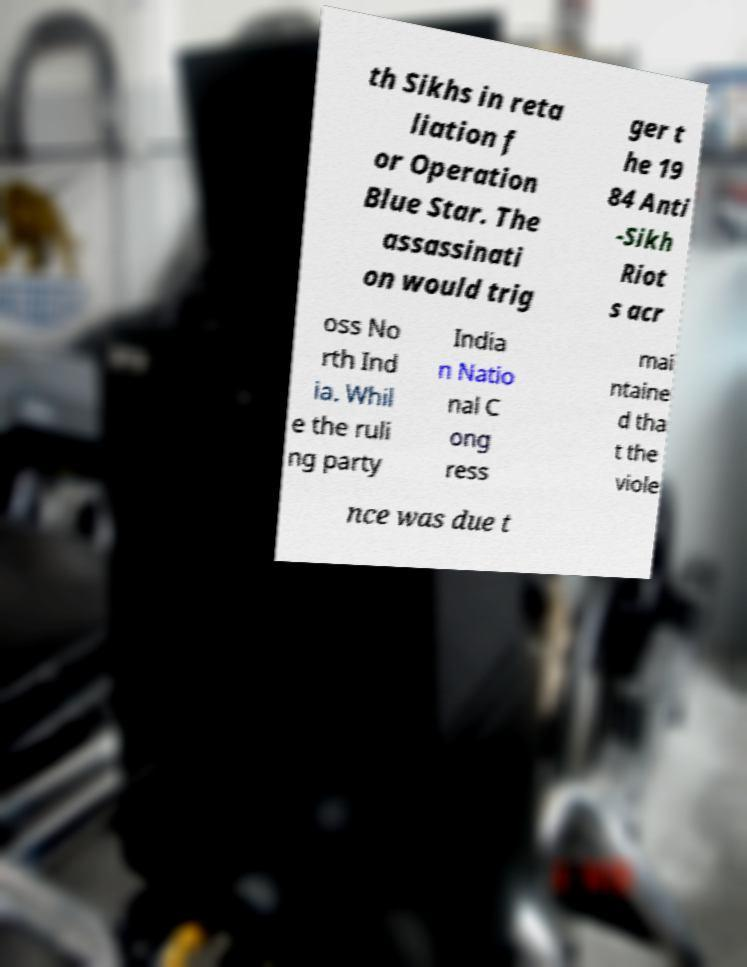Please identify and transcribe the text found in this image. th Sikhs in reta liation f or Operation Blue Star. The assassinati on would trig ger t he 19 84 Anti -Sikh Riot s acr oss No rth Ind ia. Whil e the ruli ng party India n Natio nal C ong ress mai ntaine d tha t the viole nce was due t 